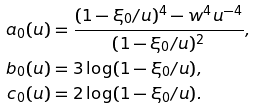Convert formula to latex. <formula><loc_0><loc_0><loc_500><loc_500>a _ { 0 } ( u ) & = \frac { ( 1 - \xi _ { 0 } / u ) ^ { 4 } - w ^ { 4 } u ^ { - 4 } } { ( 1 - \xi _ { 0 } / u ) ^ { 2 } } , \\ b _ { 0 } ( u ) & = 3 \log ( 1 - \xi _ { 0 } / u ) , \\ c _ { 0 } ( u ) & = 2 \log ( 1 - \xi _ { 0 } / u ) .</formula> 